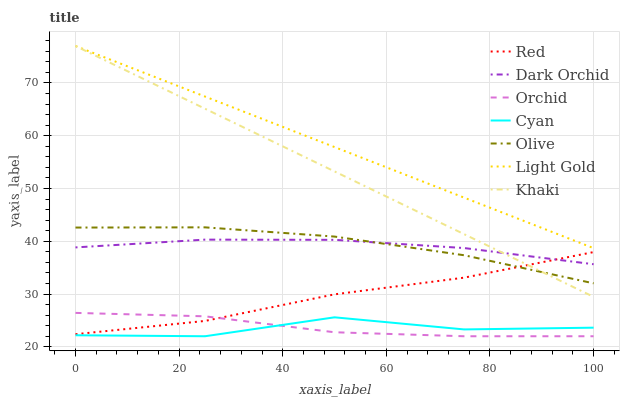Does Cyan have the minimum area under the curve?
Answer yes or no. Yes. Does Light Gold have the maximum area under the curve?
Answer yes or no. Yes. Does Dark Orchid have the minimum area under the curve?
Answer yes or no. No. Does Dark Orchid have the maximum area under the curve?
Answer yes or no. No. Is Light Gold the smoothest?
Answer yes or no. Yes. Is Cyan the roughest?
Answer yes or no. Yes. Is Dark Orchid the smoothest?
Answer yes or no. No. Is Dark Orchid the roughest?
Answer yes or no. No. Does Dark Orchid have the lowest value?
Answer yes or no. No. Does Light Gold have the highest value?
Answer yes or no. Yes. Does Dark Orchid have the highest value?
Answer yes or no. No. Is Cyan less than Khaki?
Answer yes or no. Yes. Is Light Gold greater than Olive?
Answer yes or no. Yes. Does Dark Orchid intersect Olive?
Answer yes or no. Yes. Is Dark Orchid less than Olive?
Answer yes or no. No. Is Dark Orchid greater than Olive?
Answer yes or no. No. Does Cyan intersect Khaki?
Answer yes or no. No. 